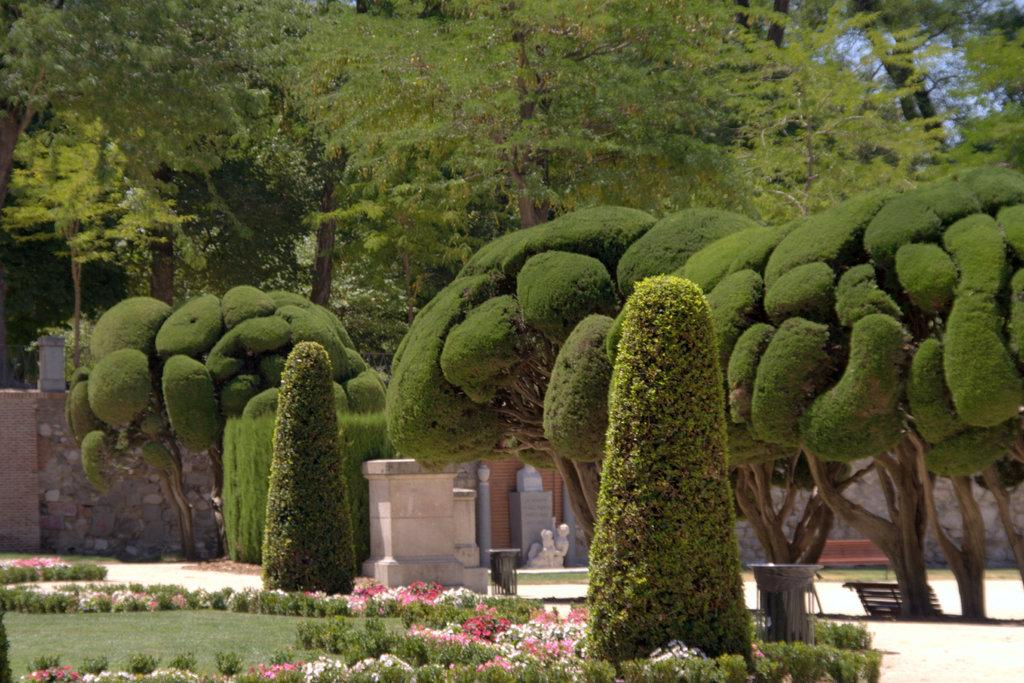What type of vegetation can be seen in the image? There is grass, plants, flowers, and trees in the image. What type of structure is present in the image? There is a wall in the image. What type of seating is available in the image? There is a bench in the image. What type of decorative elements are present in the image? There are statues in the image. What part of the natural environment is visible in the image? The sky is visible in the image. What type of meat is being grilled on the barbecue in the image? There is no barbecue or meat present in the image; it features vegetation, a wall, a bench, and statues. 